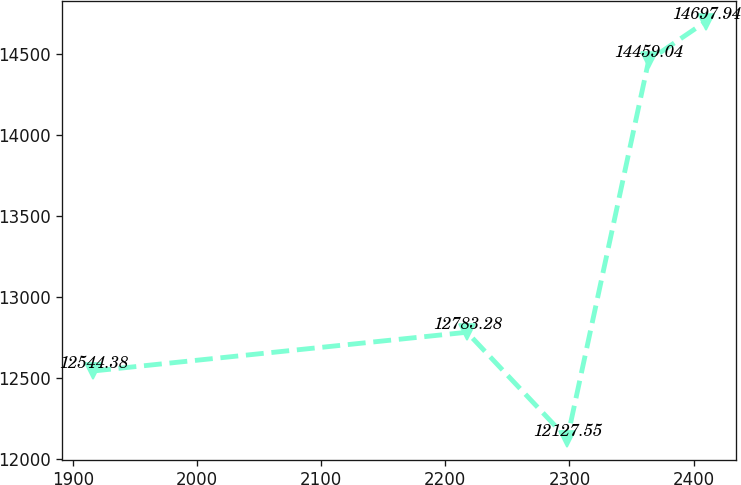Convert chart. <chart><loc_0><loc_0><loc_500><loc_500><line_chart><ecel><fcel>Unnamed: 1<nl><fcel>1916.15<fcel>12544.4<nl><fcel>2217.42<fcel>12783.3<nl><fcel>2298.19<fcel>12127.5<nl><fcel>2363.83<fcel>14459<nl><fcel>2409.84<fcel>14697.9<nl></chart> 